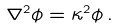Convert formula to latex. <formula><loc_0><loc_0><loc_500><loc_500>\nabla ^ { 2 } \phi = \kappa ^ { 2 } \phi \, .</formula> 